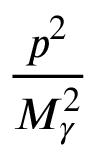<formula> <loc_0><loc_0><loc_500><loc_500>\frac { p ^ { 2 } } { M _ { \gamma } ^ { 2 } }</formula> 